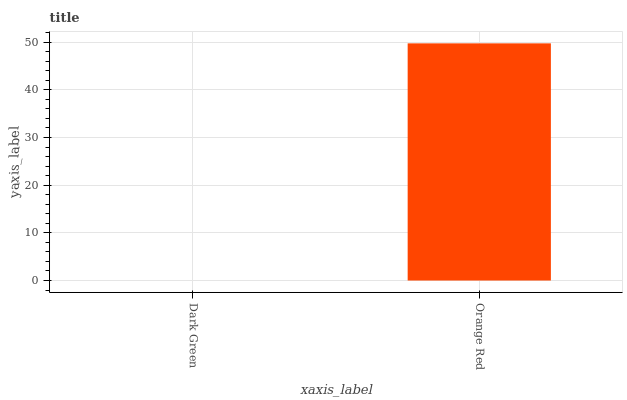Is Dark Green the minimum?
Answer yes or no. Yes. Is Orange Red the maximum?
Answer yes or no. Yes. Is Orange Red the minimum?
Answer yes or no. No. Is Orange Red greater than Dark Green?
Answer yes or no. Yes. Is Dark Green less than Orange Red?
Answer yes or no. Yes. Is Dark Green greater than Orange Red?
Answer yes or no. No. Is Orange Red less than Dark Green?
Answer yes or no. No. Is Orange Red the high median?
Answer yes or no. Yes. Is Dark Green the low median?
Answer yes or no. Yes. Is Dark Green the high median?
Answer yes or no. No. Is Orange Red the low median?
Answer yes or no. No. 